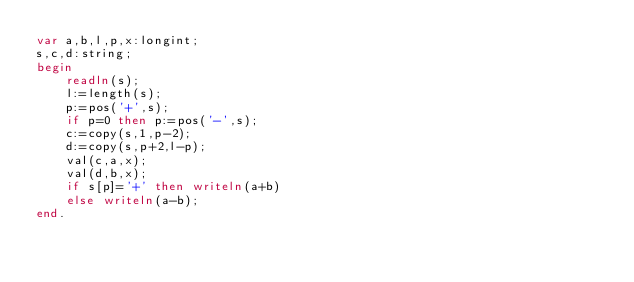<code> <loc_0><loc_0><loc_500><loc_500><_Pascal_>var a,b,l,p,x:longint;
s,c,d:string;
begin
    readln(s);
    l:=length(s);
    p:=pos('+',s);
    if p=0 then p:=pos('-',s);
    c:=copy(s,1,p-2);
    d:=copy(s,p+2,l-p);
    val(c,a,x);
    val(d,b,x);
    if s[p]='+' then writeln(a+b)
    else writeln(a-b);
end.
</code> 